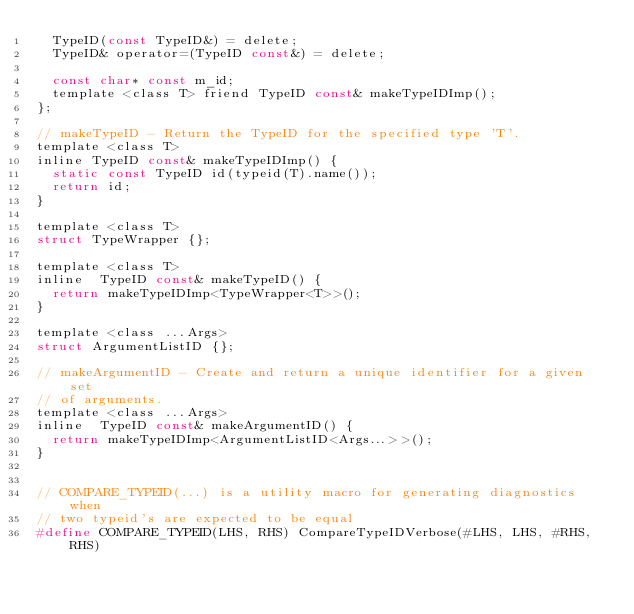<code> <loc_0><loc_0><loc_500><loc_500><_C_>  TypeID(const TypeID&) = delete;
  TypeID& operator=(TypeID const&) = delete;

  const char* const m_id;
  template <class T> friend TypeID const& makeTypeIDImp();
};

// makeTypeID - Return the TypeID for the specified type 'T'.
template <class T>
inline TypeID const& makeTypeIDImp() {
  static const TypeID id(typeid(T).name());
  return id;
}

template <class T>
struct TypeWrapper {};

template <class T>
inline  TypeID const& makeTypeID() {
  return makeTypeIDImp<TypeWrapper<T>>();
}

template <class ...Args>
struct ArgumentListID {};

// makeArgumentID - Create and return a unique identifier for a given set
// of arguments.
template <class ...Args>
inline  TypeID const& makeArgumentID() {
  return makeTypeIDImp<ArgumentListID<Args...>>();
}


// COMPARE_TYPEID(...) is a utility macro for generating diagnostics when
// two typeid's are expected to be equal
#define COMPARE_TYPEID(LHS, RHS) CompareTypeIDVerbose(#LHS, LHS, #RHS, RHS)</code> 